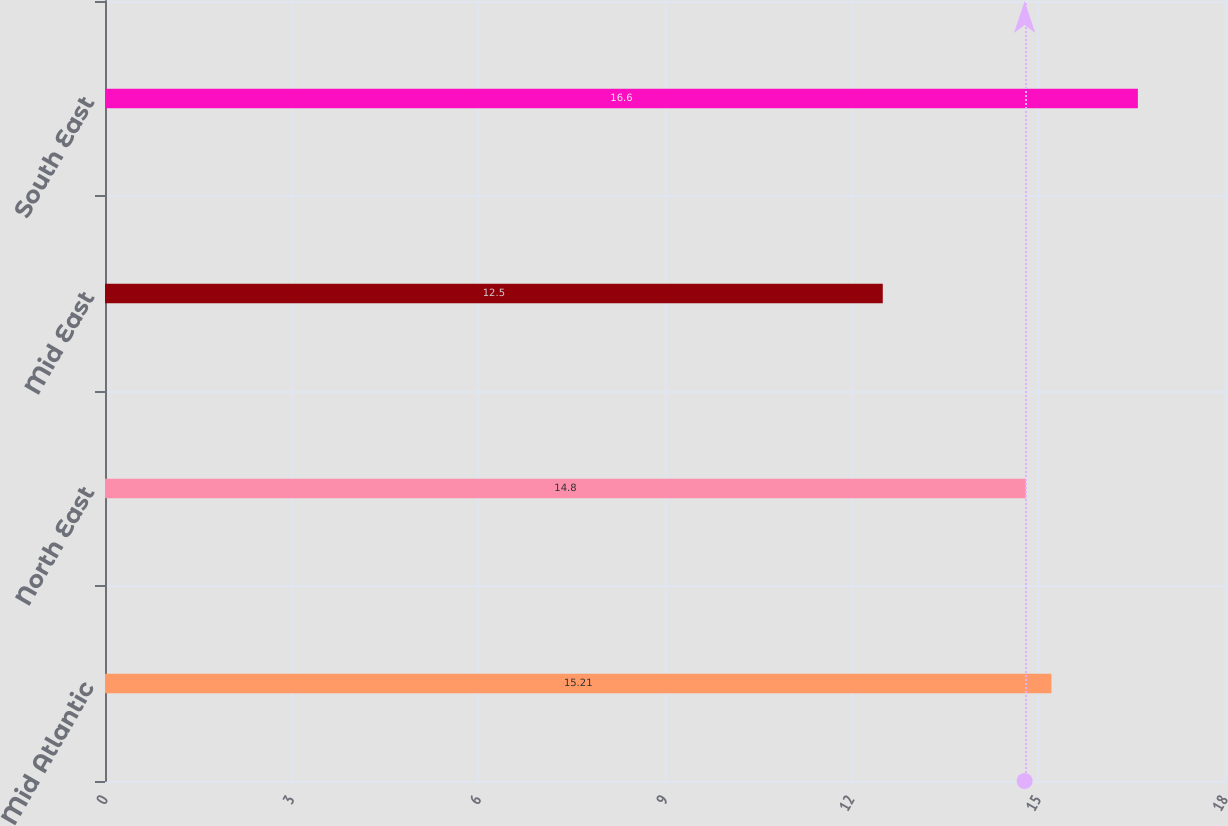Convert chart to OTSL. <chart><loc_0><loc_0><loc_500><loc_500><bar_chart><fcel>Mid Atlantic<fcel>North East<fcel>Mid East<fcel>South East<nl><fcel>15.21<fcel>14.8<fcel>12.5<fcel>16.6<nl></chart> 